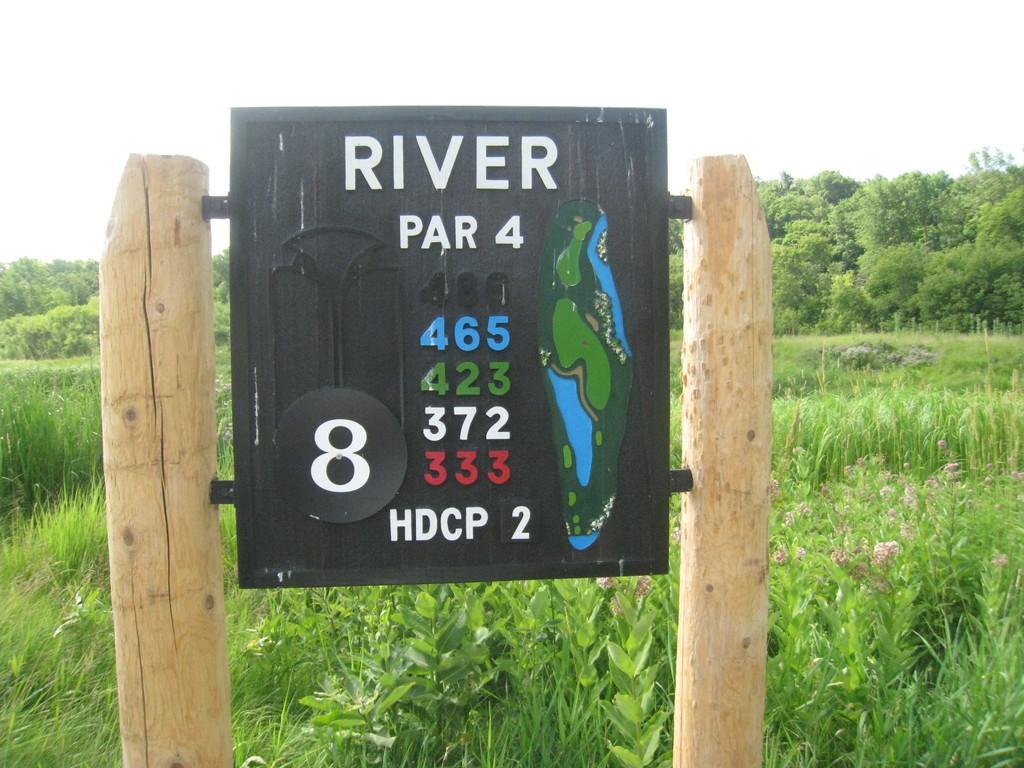Please provide a concise description of this image. In this picture there are two wooden poles. In between them, there is a board. On the board, there is a text and pictures. At the bottom, there are plants and grass. In the background there are trees and sky. 